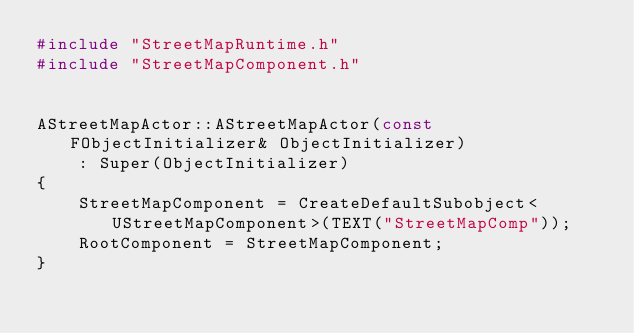Convert code to text. <code><loc_0><loc_0><loc_500><loc_500><_C++_>#include "StreetMapRuntime.h"
#include "StreetMapComponent.h"


AStreetMapActor::AStreetMapActor(const FObjectInitializer& ObjectInitializer)
	: Super(ObjectInitializer)
{
	StreetMapComponent = CreateDefaultSubobject<UStreetMapComponent>(TEXT("StreetMapComp"));
	RootComponent = StreetMapComponent;
}</code> 